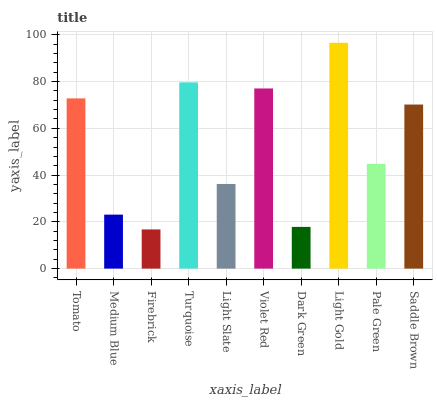Is Medium Blue the minimum?
Answer yes or no. No. Is Medium Blue the maximum?
Answer yes or no. No. Is Tomato greater than Medium Blue?
Answer yes or no. Yes. Is Medium Blue less than Tomato?
Answer yes or no. Yes. Is Medium Blue greater than Tomato?
Answer yes or no. No. Is Tomato less than Medium Blue?
Answer yes or no. No. Is Saddle Brown the high median?
Answer yes or no. Yes. Is Pale Green the low median?
Answer yes or no. Yes. Is Medium Blue the high median?
Answer yes or no. No. Is Medium Blue the low median?
Answer yes or no. No. 